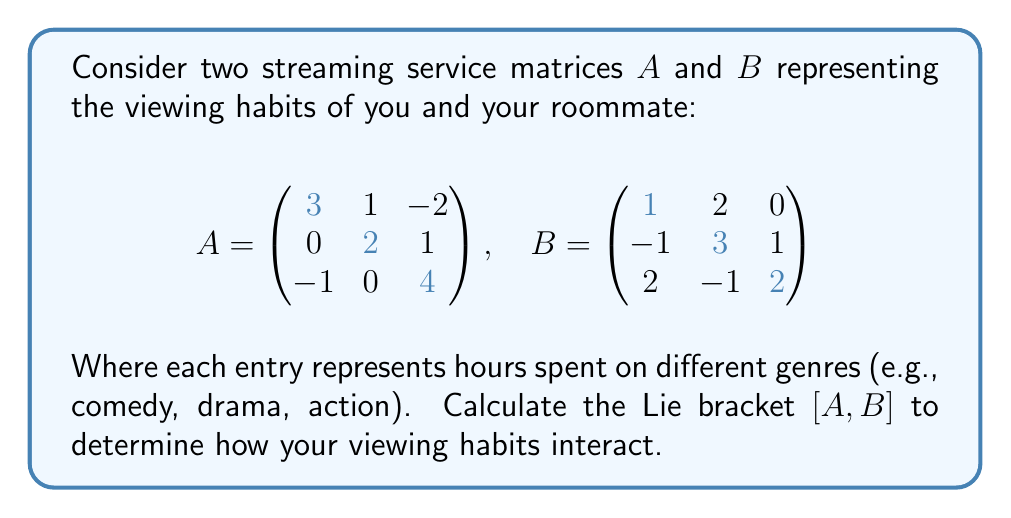Can you answer this question? To solve this problem, we need to follow these steps:

1) Recall that the Lie bracket $[A,B]$ is defined as $AB - BA$.

2) First, let's calculate $AB$:

   $$AB = \begin{pmatrix}
   3 & 1 & -2 \\
   0 & 2 & 1 \\
   -1 & 0 & 4
   \end{pmatrix} \begin{pmatrix}
   1 & 2 & 0 \\
   -1 & 3 & 1 \\
   2 & -1 & 2
   \end{pmatrix}$$

   $$AB = \begin{pmatrix}
   (3)(1) + (1)(-1) + (-2)(2) & (3)(2) + (1)(3) + (-2)(-1) & (3)(0) + (1)(1) + (-2)(2) \\
   (0)(1) + (2)(-1) + (1)(2) & (0)(2) + (2)(3) + (1)(-1) & (0)(0) + (2)(1) + (1)(2) \\
   (-1)(1) + (0)(-1) + (4)(2) & (-1)(2) + (0)(3) + (4)(-1) & (-1)(0) + (0)(1) + (4)(2)
   \end{pmatrix}$$

   $$AB = \begin{pmatrix}
   0 & 9 & -3 \\
   0 & 5 & 4 \\
   7 & -6 & 8
   \end{pmatrix}$$

3) Now, let's calculate $BA$:

   $$BA = \begin{pmatrix}
   1 & 2 & 0 \\
   -1 & 3 & 1 \\
   2 & -1 & 2
   \end{pmatrix} \begin{pmatrix}
   3 & 1 & -2 \\
   0 & 2 & 1 \\
   -1 & 0 & 4
   \end{pmatrix}$$

   $$BA = \begin{pmatrix}
   (1)(3) + (2)(0) + (0)(-1) & (1)(1) + (2)(2) + (0)(0) & (1)(-2) + (2)(1) + (0)(4) \\
   (-1)(3) + (3)(0) + (1)(-1) & (-1)(1) + (3)(2) + (1)(0) & (-1)(-2) + (3)(1) + (1)(4) \\
   (2)(3) + (-1)(0) + (2)(-1) & (2)(1) + (-1)(2) + (2)(0) & (2)(-2) + (-1)(1) + (2)(4)
   \end{pmatrix}$$

   $$BA = \begin{pmatrix}
   3 & 5 & 0 \\
   -4 & 5 & 7 \\
   4 & 0 & 7
   \end{pmatrix}$$

4) Finally, we can calculate $[A,B] = AB - BA$:

   $$[A,B] = \begin{pmatrix}
   0 & 9 & -3 \\
   0 & 5 & 4 \\
   7 & -6 & 8
   \end{pmatrix} - \begin{pmatrix}
   3 & 5 & 0 \\
   -4 & 5 & 7 \\
   4 & 0 & 7
   \end{pmatrix}$$

   $$[A,B] = \begin{pmatrix}
   -3 & 4 & -3 \\
   4 & 0 & -3 \\
   3 & -6 & 1
   \end{pmatrix}$$
Answer: $$[A,B] = \begin{pmatrix}
-3 & 4 & -3 \\
4 & 0 & -3 \\
3 & -6 & 1
\end{pmatrix}$$ 